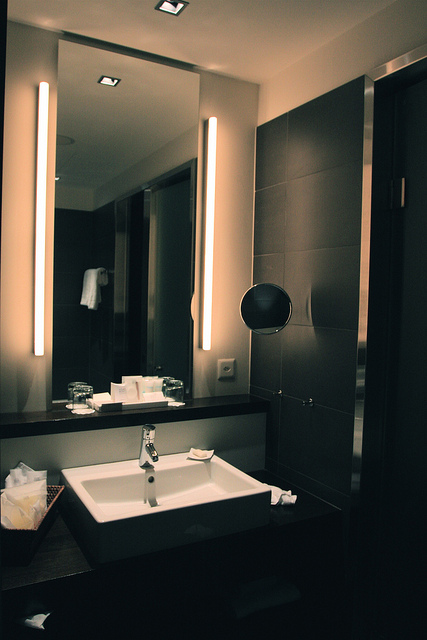Are there any items near the sink? Yes, near the sink, there are several items including multiple soap dispensers, glass containers, and a napkin holder, contributing to the cleanliness and utility of the space. 